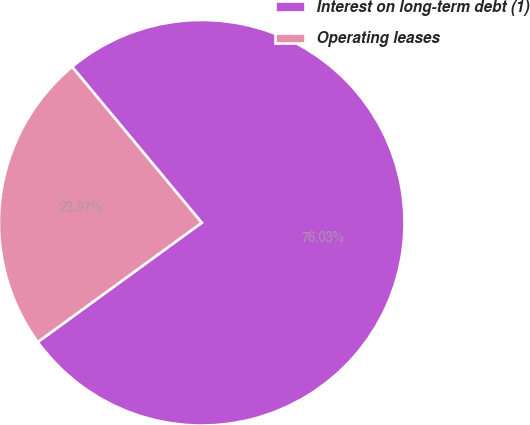Convert chart. <chart><loc_0><loc_0><loc_500><loc_500><pie_chart><fcel>Interest on long-term debt (1)<fcel>Operating leases<nl><fcel>76.03%<fcel>23.97%<nl></chart> 